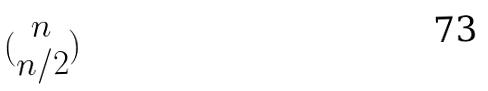<formula> <loc_0><loc_0><loc_500><loc_500>( \begin{matrix} n \\ n / 2 \end{matrix} )</formula> 